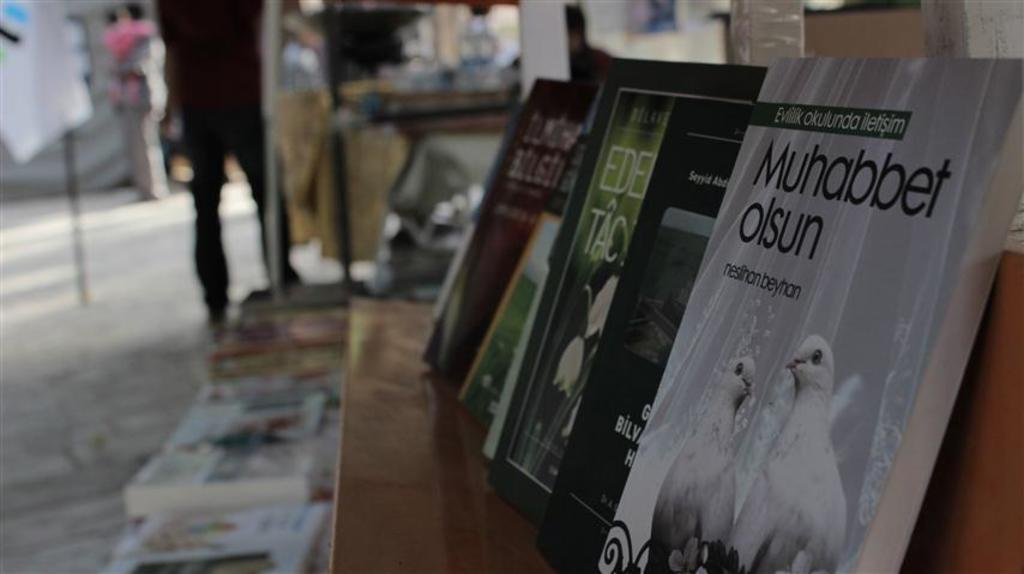<image>
Render a clear and concise summary of the photo. Books on a shelf with the saying Muhabbet Olsun. 